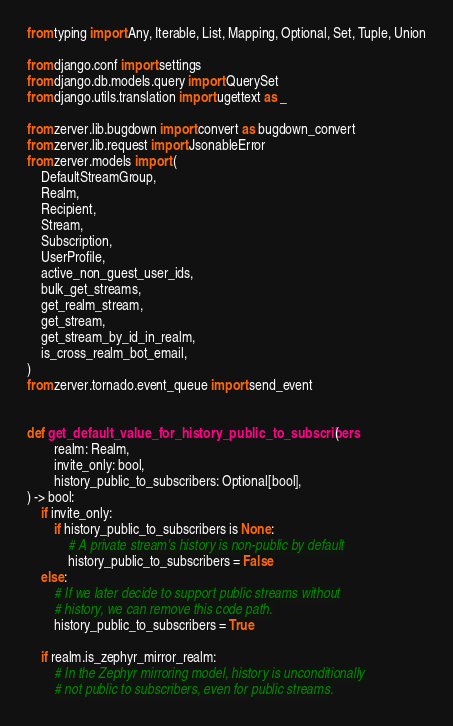<code> <loc_0><loc_0><loc_500><loc_500><_Python_>from typing import Any, Iterable, List, Mapping, Optional, Set, Tuple, Union

from django.conf import settings
from django.db.models.query import QuerySet
from django.utils.translation import ugettext as _

from zerver.lib.bugdown import convert as bugdown_convert
from zerver.lib.request import JsonableError
from zerver.models import (
    DefaultStreamGroup,
    Realm,
    Recipient,
    Stream,
    Subscription,
    UserProfile,
    active_non_guest_user_ids,
    bulk_get_streams,
    get_realm_stream,
    get_stream,
    get_stream_by_id_in_realm,
    is_cross_realm_bot_email,
)
from zerver.tornado.event_queue import send_event


def get_default_value_for_history_public_to_subscribers(
        realm: Realm,
        invite_only: bool,
        history_public_to_subscribers: Optional[bool],
) -> bool:
    if invite_only:
        if history_public_to_subscribers is None:
            # A private stream's history is non-public by default
            history_public_to_subscribers = False
    else:
        # If we later decide to support public streams without
        # history, we can remove this code path.
        history_public_to_subscribers = True

    if realm.is_zephyr_mirror_realm:
        # In the Zephyr mirroring model, history is unconditionally
        # not public to subscribers, even for public streams.</code> 